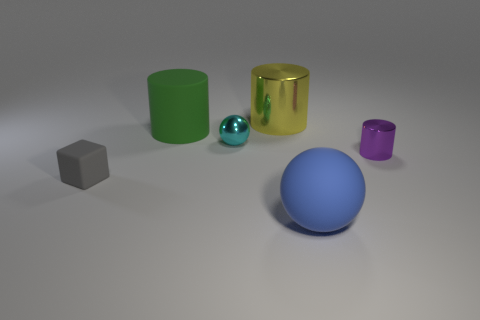Subtract all metal cylinders. How many cylinders are left? 1 Add 3 yellow shiny balls. How many objects exist? 9 Subtract all cubes. How many objects are left? 5 Subtract all large cyan shiny cubes. Subtract all tiny gray objects. How many objects are left? 5 Add 5 large objects. How many large objects are left? 8 Add 6 gray rubber cylinders. How many gray rubber cylinders exist? 6 Subtract 0 purple spheres. How many objects are left? 6 